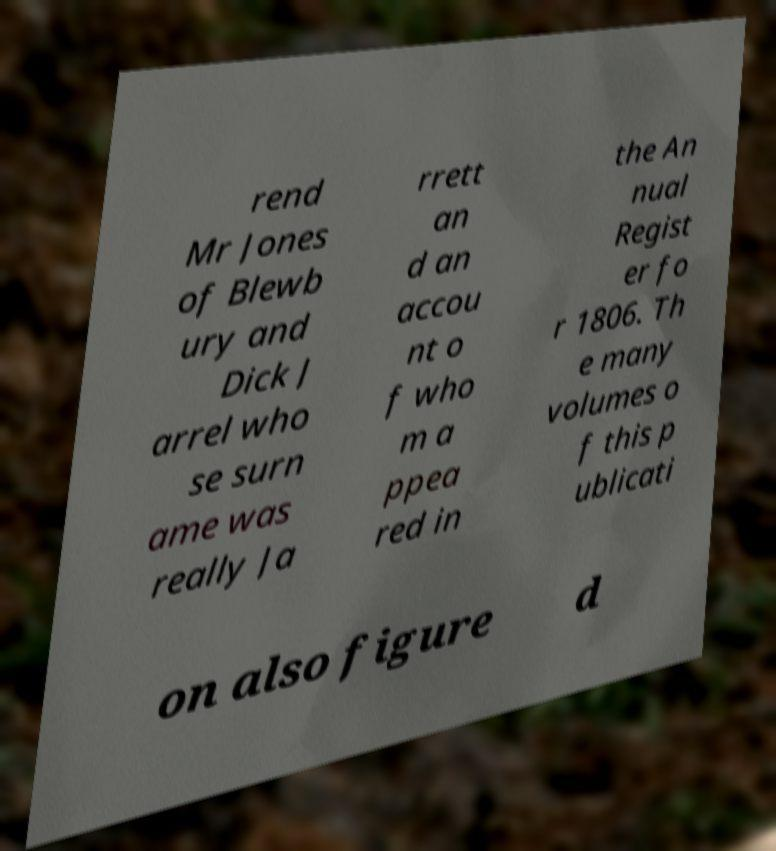Can you accurately transcribe the text from the provided image for me? rend Mr Jones of Blewb ury and Dick J arrel who se surn ame was really Ja rrett an d an accou nt o f who m a ppea red in the An nual Regist er fo r 1806. Th e many volumes o f this p ublicati on also figure d 